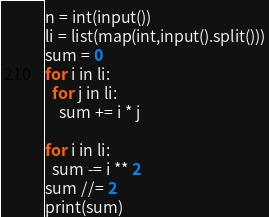Convert code to text. <code><loc_0><loc_0><loc_500><loc_500><_Python_>n = int(input())
li = list(map(int,input().split()))
sum = 0
for i in li:
  for j in li:
    sum += i * j

for i in li:
  sum -= i ** 2
sum //= 2
print(sum)</code> 